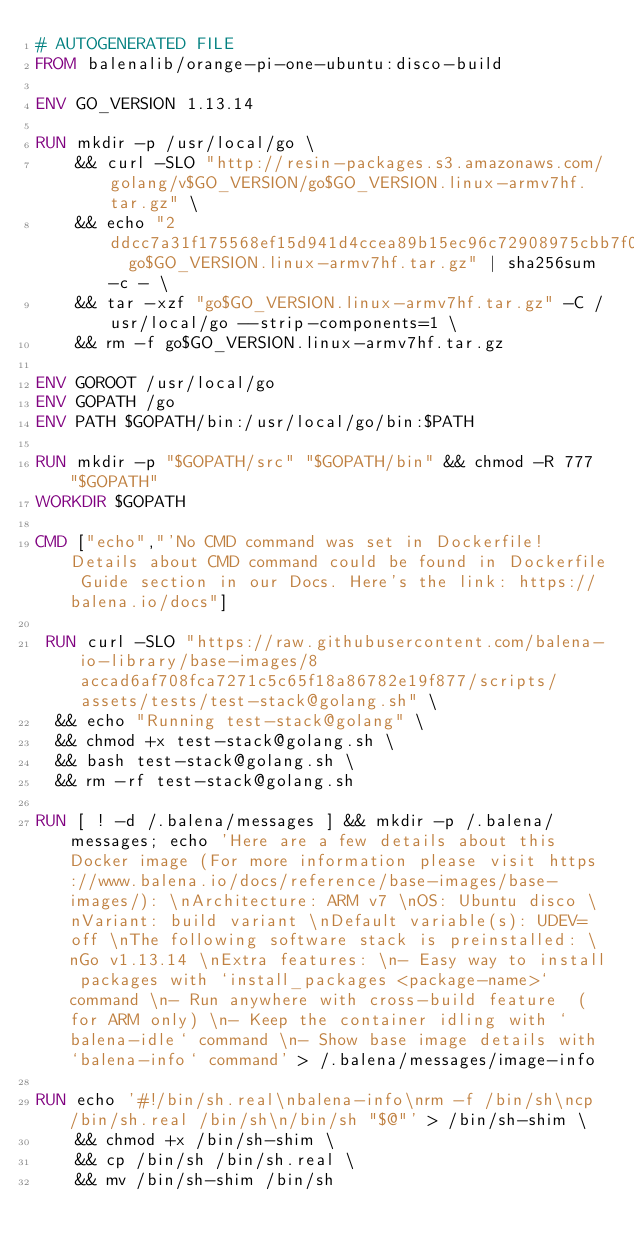Convert code to text. <code><loc_0><loc_0><loc_500><loc_500><_Dockerfile_># AUTOGENERATED FILE
FROM balenalib/orange-pi-one-ubuntu:disco-build

ENV GO_VERSION 1.13.14

RUN mkdir -p /usr/local/go \
	&& curl -SLO "http://resin-packages.s3.amazonaws.com/golang/v$GO_VERSION/go$GO_VERSION.linux-armv7hf.tar.gz" \
	&& echo "2ddcc7a31f175568ef15d941d4ccea89b15ec96c72908975cbb7f04ccb49fa0d  go$GO_VERSION.linux-armv7hf.tar.gz" | sha256sum -c - \
	&& tar -xzf "go$GO_VERSION.linux-armv7hf.tar.gz" -C /usr/local/go --strip-components=1 \
	&& rm -f go$GO_VERSION.linux-armv7hf.tar.gz

ENV GOROOT /usr/local/go
ENV GOPATH /go
ENV PATH $GOPATH/bin:/usr/local/go/bin:$PATH

RUN mkdir -p "$GOPATH/src" "$GOPATH/bin" && chmod -R 777 "$GOPATH"
WORKDIR $GOPATH

CMD ["echo","'No CMD command was set in Dockerfile! Details about CMD command could be found in Dockerfile Guide section in our Docs. Here's the link: https://balena.io/docs"]

 RUN curl -SLO "https://raw.githubusercontent.com/balena-io-library/base-images/8accad6af708fca7271c5c65f18a86782e19f877/scripts/assets/tests/test-stack@golang.sh" \
  && echo "Running test-stack@golang" \
  && chmod +x test-stack@golang.sh \
  && bash test-stack@golang.sh \
  && rm -rf test-stack@golang.sh 

RUN [ ! -d /.balena/messages ] && mkdir -p /.balena/messages; echo 'Here are a few details about this Docker image (For more information please visit https://www.balena.io/docs/reference/base-images/base-images/): \nArchitecture: ARM v7 \nOS: Ubuntu disco \nVariant: build variant \nDefault variable(s): UDEV=off \nThe following software stack is preinstalled: \nGo v1.13.14 \nExtra features: \n- Easy way to install packages with `install_packages <package-name>` command \n- Run anywhere with cross-build feature  (for ARM only) \n- Keep the container idling with `balena-idle` command \n- Show base image details with `balena-info` command' > /.balena/messages/image-info

RUN echo '#!/bin/sh.real\nbalena-info\nrm -f /bin/sh\ncp /bin/sh.real /bin/sh\n/bin/sh "$@"' > /bin/sh-shim \
	&& chmod +x /bin/sh-shim \
	&& cp /bin/sh /bin/sh.real \
	&& mv /bin/sh-shim /bin/sh</code> 